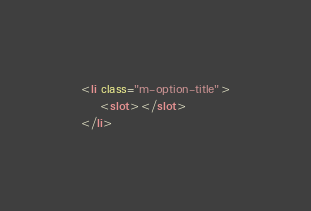Convert code to text. <code><loc_0><loc_0><loc_500><loc_500><_HTML_><li class="m-option-title">
    <slot></slot>
</li>
</code> 